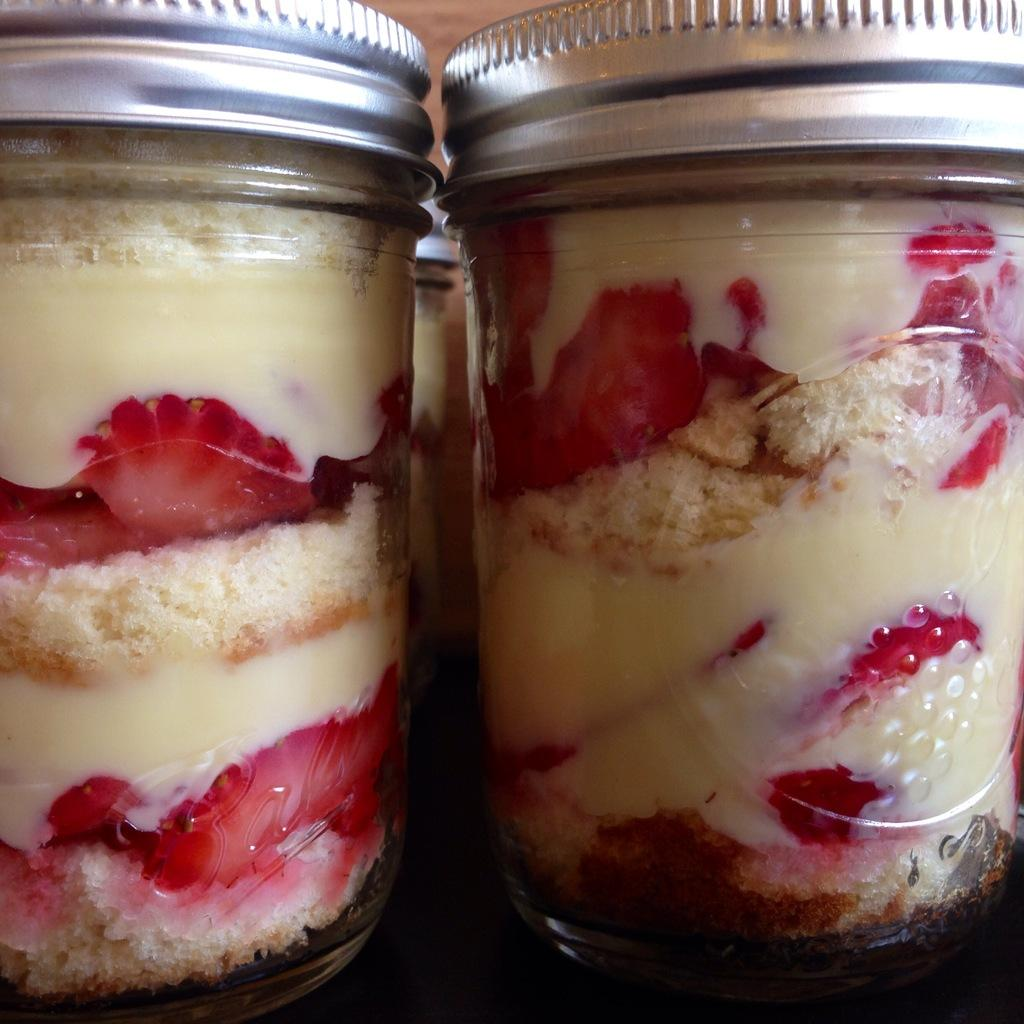How many jars are visible in the image? There are three jars in the image. What is inside the jars? The jars contain food items. Where are the jars located? The jars are placed on a table. What type of jam is being prepared by the fireman in the image? There is no fireman or jam preparation in the image; it only features three jars containing food items on a table. 